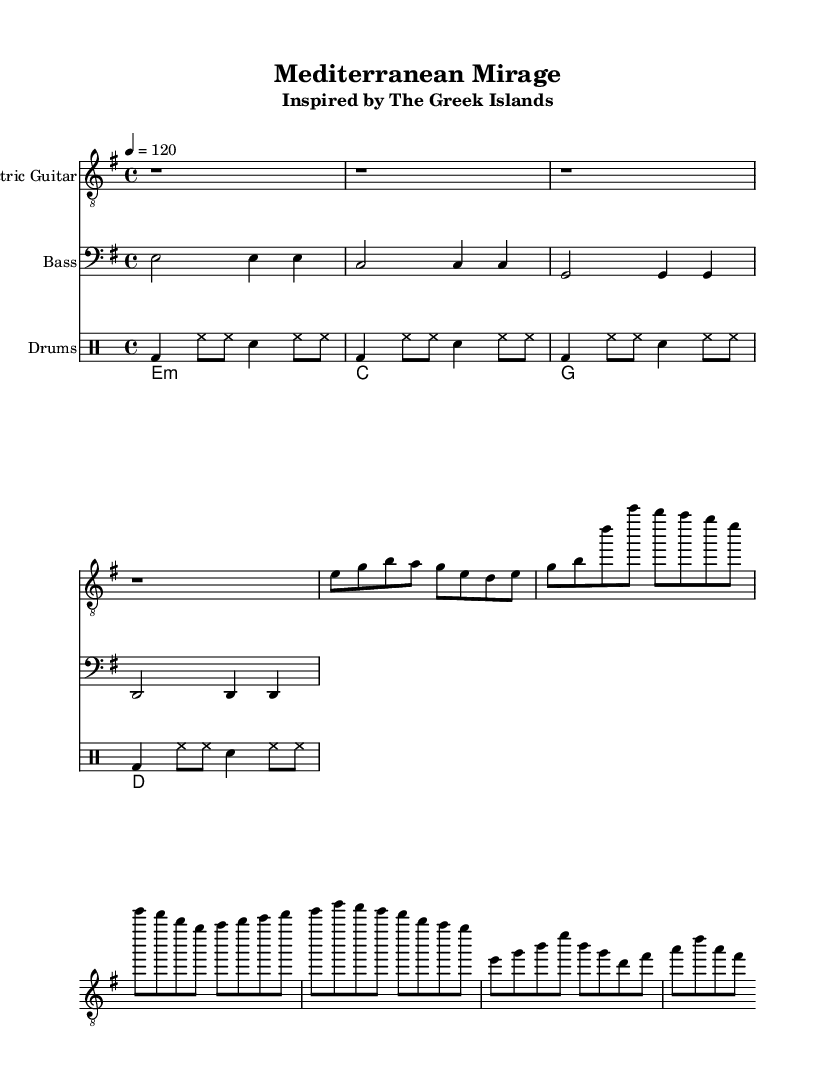What is the key signature of this music? The key signature is E minor, which contains one sharp (F#). This is derived from the global music context provided at the beginning of the code.
Answer: E minor What is the time signature of this music? The time signature is 4/4, which means there are four beats per measure and a quarter note gets one beat. This information is also stated in the global music context.
Answer: 4/4 What is the tempo marking of this piece? The tempo marking is 120 beats per minute, indicated as "4 = 120" in the global context. This means the music should be played at a moderate tempo.
Answer: 120 How many measures are in the guitar riff? The guitar riff consists of 8 measures, which can be counted by examining the notes and rests under the Electric Guitar staff section.
Answer: 8 What is the first chord played by the keyboard? The first chord played by the keyboard is E minor, as denoted by "e1:m" in the keyboard part under chordmode. This indicates the chord played is an E minor triad.
Answer: E minor How is the drum pattern structured? The drum pattern consists of a consistent pattern of bass drum (bd), hi-hat (hh), and snare (sn) notes over 4 measures. This pattern repeats throughout, making it easy to recognize.
Answer: 4 measures What type of scale is primarily used in the Electric Guitar part? The Electric Guitar primarily uses the E minor scale, as most of the notes (e, g, b, a, d, etc.) correspond to this scale, which includes the notes found in its natural form.
Answer: E minor scale 